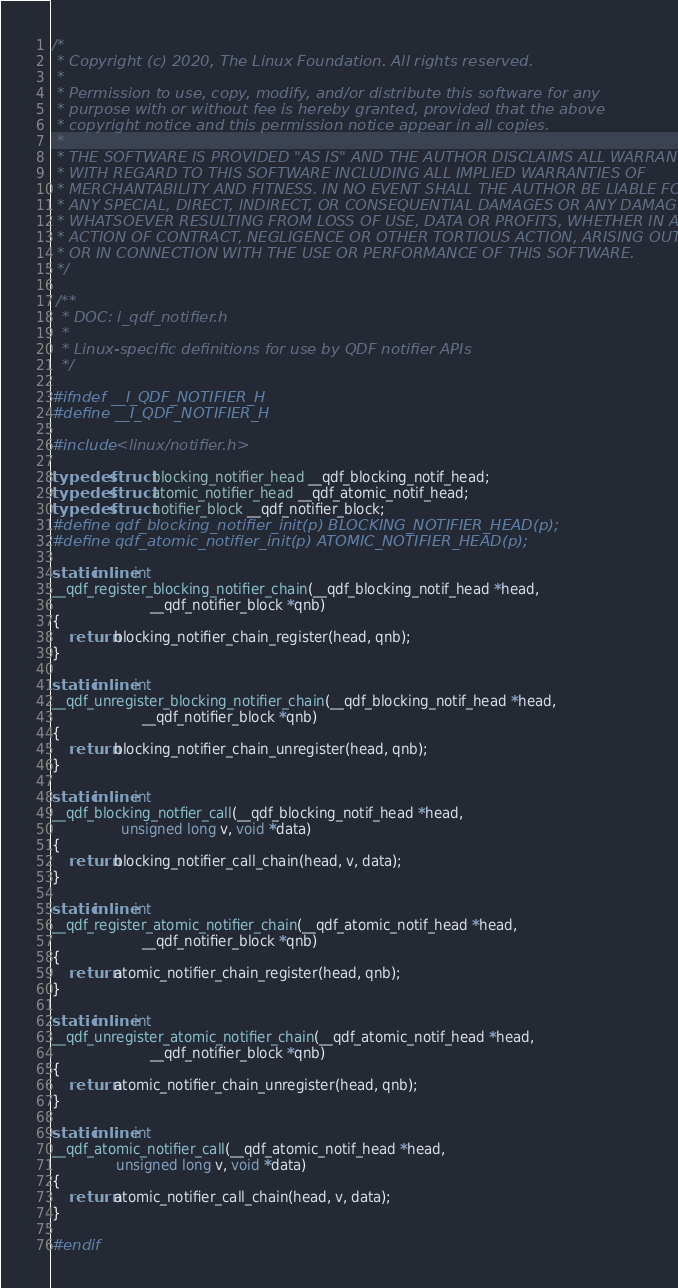Convert code to text. <code><loc_0><loc_0><loc_500><loc_500><_C_>/*
 * Copyright (c) 2020, The Linux Foundation. All rights reserved.
 *
 * Permission to use, copy, modify, and/or distribute this software for any
 * purpose with or without fee is hereby granted, provided that the above
 * copyright notice and this permission notice appear in all copies.
 *
 * THE SOFTWARE IS PROVIDED "AS IS" AND THE AUTHOR DISCLAIMS ALL WARRANTIES
 * WITH REGARD TO THIS SOFTWARE INCLUDING ALL IMPLIED WARRANTIES OF
 * MERCHANTABILITY AND FITNESS. IN NO EVENT SHALL THE AUTHOR BE LIABLE FOR
 * ANY SPECIAL, DIRECT, INDIRECT, OR CONSEQUENTIAL DAMAGES OR ANY DAMAGES
 * WHATSOEVER RESULTING FROM LOSS OF USE, DATA OR PROFITS, WHETHER IN AN
 * ACTION OF CONTRACT, NEGLIGENCE OR OTHER TORTIOUS ACTION, ARISING OUT OF
 * OR IN CONNECTION WITH THE USE OR PERFORMANCE OF THIS SOFTWARE.
 */

 /**
  * DOC: i_qdf_notifier.h
  *
  * Linux-specific definitions for use by QDF notifier APIs
  */

#ifndef __I_QDF_NOTIFIER_H
#define __I_QDF_NOTIFIER_H

#include <linux/notifier.h>

typedef struct blocking_notifier_head __qdf_blocking_notif_head;
typedef struct atomic_notifier_head __qdf_atomic_notif_head;
typedef struct notifier_block __qdf_notifier_block;
#define qdf_blocking_notifier_init(p) BLOCKING_NOTIFIER_HEAD(p);
#define qdf_atomic_notifier_init(p) ATOMIC_NOTIFIER_HEAD(p);

static inline int
__qdf_register_blocking_notifier_chain(__qdf_blocking_notif_head *head,
				       __qdf_notifier_block *qnb)
{
	return blocking_notifier_chain_register(head, qnb);
}

static inline int
__qdf_unregister_blocking_notifier_chain(__qdf_blocking_notif_head *head,
					 __qdf_notifier_block *qnb)
{
	return blocking_notifier_chain_unregister(head, qnb);
}

static inline int
__qdf_blocking_notfier_call(__qdf_blocking_notif_head *head,
			    unsigned long v, void *data)
{
	return blocking_notifier_call_chain(head, v, data);
}

static inline int
__qdf_register_atomic_notifier_chain(__qdf_atomic_notif_head *head,
				     __qdf_notifier_block *qnb)
{
	return atomic_notifier_chain_register(head, qnb);
}

static inline int
__qdf_unregister_atomic_notifier_chain(__qdf_atomic_notif_head *head,
				       __qdf_notifier_block *qnb)
{
	return atomic_notifier_chain_unregister(head, qnb);
}

static inline int
__qdf_atomic_notifier_call(__qdf_atomic_notif_head *head,
			   unsigned long v, void *data)
{
	return atomic_notifier_call_chain(head, v, data);
}

#endif
</code> 